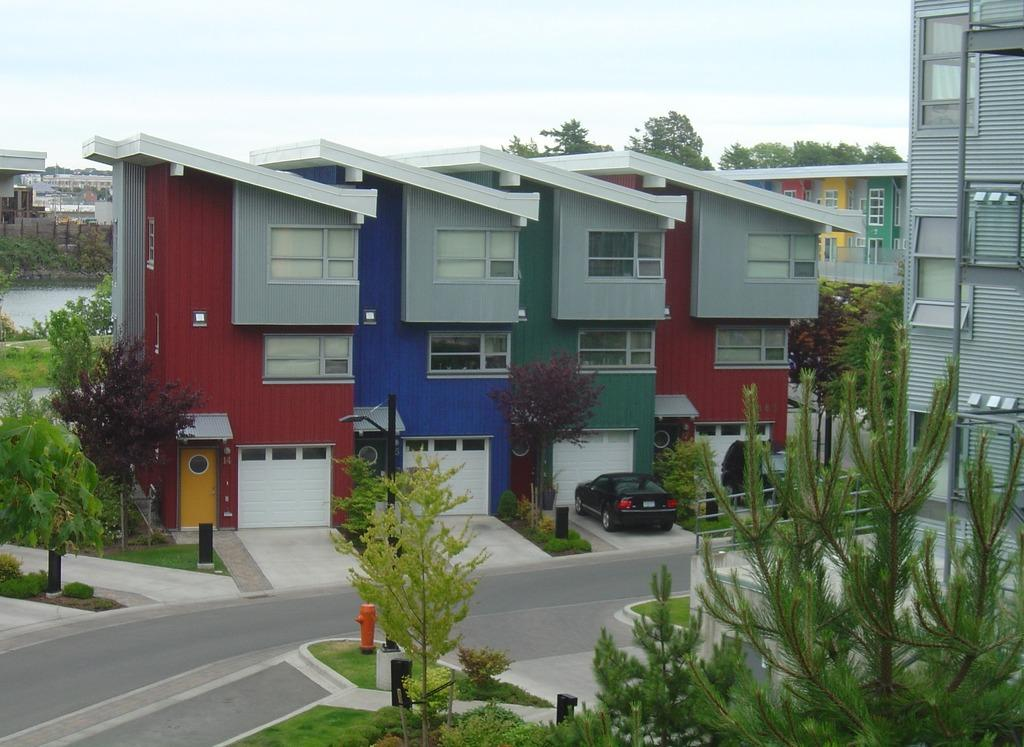What type of structures can be seen in the image? There are buildings in the image. What vehicle is parked in the image? A black color car is parked in the image. What type of vegetation is present in the image? There are trees in the image. What is visible at the top of the image? The sky is visible at the top of the image. What is the weather condition in the image? The sky appears to be sunny, suggesting a clear and bright day. Can you see the man's wound on his partner's arm in the image? There is no man or partner present in the image, and therefore no wound can be observed. 